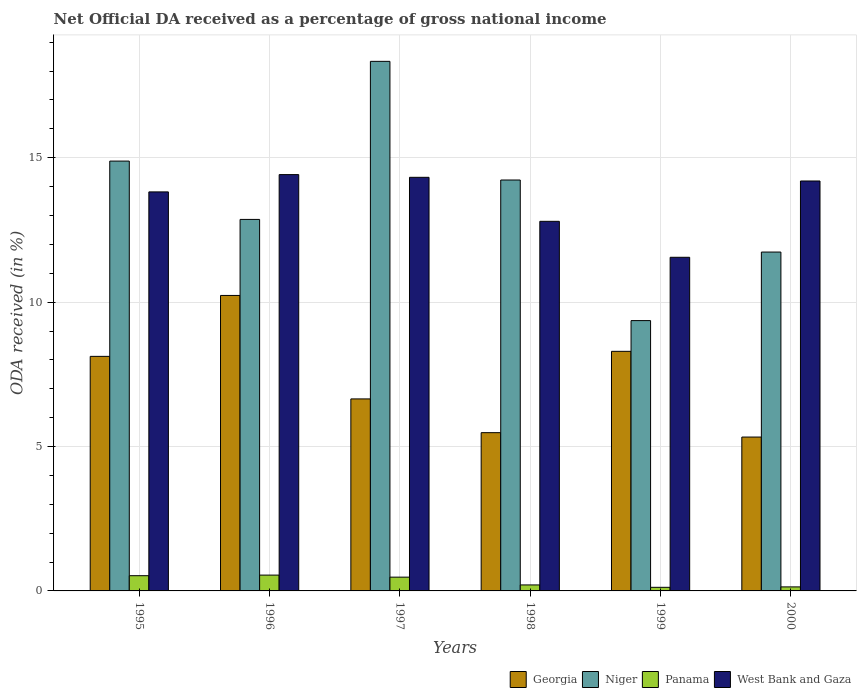How many different coloured bars are there?
Give a very brief answer. 4. Are the number of bars per tick equal to the number of legend labels?
Give a very brief answer. Yes. How many bars are there on the 4th tick from the left?
Give a very brief answer. 4. How many bars are there on the 1st tick from the right?
Provide a short and direct response. 4. What is the net official DA received in West Bank and Gaza in 1997?
Provide a succinct answer. 14.32. Across all years, what is the maximum net official DA received in West Bank and Gaza?
Offer a terse response. 14.42. Across all years, what is the minimum net official DA received in Panama?
Your answer should be compact. 0.12. In which year was the net official DA received in Niger minimum?
Your answer should be compact. 1999. What is the total net official DA received in West Bank and Gaza in the graph?
Offer a very short reply. 81.1. What is the difference between the net official DA received in West Bank and Gaza in 1995 and that in 1997?
Provide a short and direct response. -0.51. What is the difference between the net official DA received in Niger in 1998 and the net official DA received in Panama in 1995?
Make the answer very short. 13.7. What is the average net official DA received in Panama per year?
Your answer should be compact. 0.34. In the year 2000, what is the difference between the net official DA received in Georgia and net official DA received in West Bank and Gaza?
Offer a terse response. -8.87. What is the ratio of the net official DA received in Panama in 1997 to that in 1998?
Provide a short and direct response. 2.3. What is the difference between the highest and the second highest net official DA received in West Bank and Gaza?
Provide a short and direct response. 0.09. What is the difference between the highest and the lowest net official DA received in Niger?
Your answer should be compact. 8.98. Is it the case that in every year, the sum of the net official DA received in Panama and net official DA received in Niger is greater than the sum of net official DA received in Georgia and net official DA received in West Bank and Gaza?
Give a very brief answer. No. What does the 1st bar from the left in 1999 represents?
Offer a terse response. Georgia. What does the 2nd bar from the right in 1996 represents?
Provide a short and direct response. Panama. How many years are there in the graph?
Your response must be concise. 6. Does the graph contain grids?
Provide a succinct answer. Yes. How many legend labels are there?
Ensure brevity in your answer.  4. How are the legend labels stacked?
Ensure brevity in your answer.  Horizontal. What is the title of the graph?
Offer a terse response. Net Official DA received as a percentage of gross national income. Does "Korea (Democratic)" appear as one of the legend labels in the graph?
Your response must be concise. No. What is the label or title of the Y-axis?
Ensure brevity in your answer.  ODA received (in %). What is the ODA received (in %) in Georgia in 1995?
Keep it short and to the point. 8.12. What is the ODA received (in %) in Niger in 1995?
Ensure brevity in your answer.  14.88. What is the ODA received (in %) of Panama in 1995?
Give a very brief answer. 0.53. What is the ODA received (in %) of West Bank and Gaza in 1995?
Provide a succinct answer. 13.82. What is the ODA received (in %) of Georgia in 1996?
Your answer should be very brief. 10.23. What is the ODA received (in %) in Niger in 1996?
Make the answer very short. 12.86. What is the ODA received (in %) in Panama in 1996?
Offer a very short reply. 0.55. What is the ODA received (in %) of West Bank and Gaza in 1996?
Make the answer very short. 14.42. What is the ODA received (in %) of Georgia in 1997?
Provide a succinct answer. 6.65. What is the ODA received (in %) of Niger in 1997?
Your response must be concise. 18.34. What is the ODA received (in %) of Panama in 1997?
Provide a succinct answer. 0.48. What is the ODA received (in %) of West Bank and Gaza in 1997?
Give a very brief answer. 14.32. What is the ODA received (in %) of Georgia in 1998?
Offer a terse response. 5.48. What is the ODA received (in %) of Niger in 1998?
Provide a short and direct response. 14.23. What is the ODA received (in %) of Panama in 1998?
Keep it short and to the point. 0.21. What is the ODA received (in %) in West Bank and Gaza in 1998?
Keep it short and to the point. 12.8. What is the ODA received (in %) of Georgia in 1999?
Make the answer very short. 8.3. What is the ODA received (in %) in Niger in 1999?
Ensure brevity in your answer.  9.36. What is the ODA received (in %) of Panama in 1999?
Your answer should be compact. 0.12. What is the ODA received (in %) in West Bank and Gaza in 1999?
Keep it short and to the point. 11.55. What is the ODA received (in %) in Georgia in 2000?
Offer a terse response. 5.33. What is the ODA received (in %) of Niger in 2000?
Make the answer very short. 11.73. What is the ODA received (in %) of Panama in 2000?
Your answer should be compact. 0.14. What is the ODA received (in %) of West Bank and Gaza in 2000?
Ensure brevity in your answer.  14.19. Across all years, what is the maximum ODA received (in %) of Georgia?
Ensure brevity in your answer.  10.23. Across all years, what is the maximum ODA received (in %) of Niger?
Ensure brevity in your answer.  18.34. Across all years, what is the maximum ODA received (in %) of Panama?
Give a very brief answer. 0.55. Across all years, what is the maximum ODA received (in %) in West Bank and Gaza?
Ensure brevity in your answer.  14.42. Across all years, what is the minimum ODA received (in %) in Georgia?
Keep it short and to the point. 5.33. Across all years, what is the minimum ODA received (in %) of Niger?
Keep it short and to the point. 9.36. Across all years, what is the minimum ODA received (in %) in Panama?
Your answer should be compact. 0.12. Across all years, what is the minimum ODA received (in %) in West Bank and Gaza?
Keep it short and to the point. 11.55. What is the total ODA received (in %) of Georgia in the graph?
Your answer should be compact. 44.11. What is the total ODA received (in %) of Niger in the graph?
Ensure brevity in your answer.  81.41. What is the total ODA received (in %) in Panama in the graph?
Ensure brevity in your answer.  2.02. What is the total ODA received (in %) in West Bank and Gaza in the graph?
Keep it short and to the point. 81.1. What is the difference between the ODA received (in %) of Georgia in 1995 and that in 1996?
Give a very brief answer. -2.11. What is the difference between the ODA received (in %) of Niger in 1995 and that in 1996?
Provide a short and direct response. 2.02. What is the difference between the ODA received (in %) in Panama in 1995 and that in 1996?
Keep it short and to the point. -0.02. What is the difference between the ODA received (in %) of West Bank and Gaza in 1995 and that in 1996?
Offer a very short reply. -0.6. What is the difference between the ODA received (in %) of Georgia in 1995 and that in 1997?
Provide a short and direct response. 1.47. What is the difference between the ODA received (in %) of Niger in 1995 and that in 1997?
Your answer should be compact. -3.45. What is the difference between the ODA received (in %) of Panama in 1995 and that in 1997?
Ensure brevity in your answer.  0.05. What is the difference between the ODA received (in %) of West Bank and Gaza in 1995 and that in 1997?
Provide a short and direct response. -0.51. What is the difference between the ODA received (in %) of Georgia in 1995 and that in 1998?
Provide a succinct answer. 2.64. What is the difference between the ODA received (in %) of Niger in 1995 and that in 1998?
Provide a short and direct response. 0.66. What is the difference between the ODA received (in %) of Panama in 1995 and that in 1998?
Give a very brief answer. 0.32. What is the difference between the ODA received (in %) of West Bank and Gaza in 1995 and that in 1998?
Your response must be concise. 1.02. What is the difference between the ODA received (in %) in Georgia in 1995 and that in 1999?
Your answer should be very brief. -0.17. What is the difference between the ODA received (in %) of Niger in 1995 and that in 1999?
Ensure brevity in your answer.  5.52. What is the difference between the ODA received (in %) of Panama in 1995 and that in 1999?
Provide a succinct answer. 0.4. What is the difference between the ODA received (in %) in West Bank and Gaza in 1995 and that in 1999?
Give a very brief answer. 2.26. What is the difference between the ODA received (in %) of Georgia in 1995 and that in 2000?
Offer a terse response. 2.79. What is the difference between the ODA received (in %) of Niger in 1995 and that in 2000?
Provide a short and direct response. 3.15. What is the difference between the ODA received (in %) of Panama in 1995 and that in 2000?
Provide a short and direct response. 0.39. What is the difference between the ODA received (in %) in West Bank and Gaza in 1995 and that in 2000?
Keep it short and to the point. -0.38. What is the difference between the ODA received (in %) of Georgia in 1996 and that in 1997?
Provide a short and direct response. 3.58. What is the difference between the ODA received (in %) of Niger in 1996 and that in 1997?
Ensure brevity in your answer.  -5.47. What is the difference between the ODA received (in %) of Panama in 1996 and that in 1997?
Provide a succinct answer. 0.07. What is the difference between the ODA received (in %) of West Bank and Gaza in 1996 and that in 1997?
Your answer should be very brief. 0.09. What is the difference between the ODA received (in %) of Georgia in 1996 and that in 1998?
Your response must be concise. 4.75. What is the difference between the ODA received (in %) in Niger in 1996 and that in 1998?
Your answer should be very brief. -1.36. What is the difference between the ODA received (in %) of Panama in 1996 and that in 1998?
Give a very brief answer. 0.34. What is the difference between the ODA received (in %) in West Bank and Gaza in 1996 and that in 1998?
Offer a terse response. 1.62. What is the difference between the ODA received (in %) of Georgia in 1996 and that in 1999?
Offer a very short reply. 1.94. What is the difference between the ODA received (in %) in Niger in 1996 and that in 1999?
Offer a very short reply. 3.5. What is the difference between the ODA received (in %) of Panama in 1996 and that in 1999?
Provide a short and direct response. 0.42. What is the difference between the ODA received (in %) in West Bank and Gaza in 1996 and that in 1999?
Keep it short and to the point. 2.86. What is the difference between the ODA received (in %) in Georgia in 1996 and that in 2000?
Offer a very short reply. 4.9. What is the difference between the ODA received (in %) of Niger in 1996 and that in 2000?
Give a very brief answer. 1.13. What is the difference between the ODA received (in %) in Panama in 1996 and that in 2000?
Offer a very short reply. 0.41. What is the difference between the ODA received (in %) in West Bank and Gaza in 1996 and that in 2000?
Your answer should be very brief. 0.22. What is the difference between the ODA received (in %) in Georgia in 1997 and that in 1998?
Ensure brevity in your answer.  1.17. What is the difference between the ODA received (in %) in Niger in 1997 and that in 1998?
Your answer should be very brief. 4.11. What is the difference between the ODA received (in %) in Panama in 1997 and that in 1998?
Provide a succinct answer. 0.27. What is the difference between the ODA received (in %) in West Bank and Gaza in 1997 and that in 1998?
Your answer should be very brief. 1.52. What is the difference between the ODA received (in %) in Georgia in 1997 and that in 1999?
Offer a very short reply. -1.65. What is the difference between the ODA received (in %) of Niger in 1997 and that in 1999?
Your response must be concise. 8.98. What is the difference between the ODA received (in %) in Panama in 1997 and that in 1999?
Give a very brief answer. 0.35. What is the difference between the ODA received (in %) of West Bank and Gaza in 1997 and that in 1999?
Offer a very short reply. 2.77. What is the difference between the ODA received (in %) in Georgia in 1997 and that in 2000?
Your answer should be compact. 1.32. What is the difference between the ODA received (in %) in Niger in 1997 and that in 2000?
Offer a terse response. 6.6. What is the difference between the ODA received (in %) in Panama in 1997 and that in 2000?
Provide a short and direct response. 0.34. What is the difference between the ODA received (in %) of West Bank and Gaza in 1997 and that in 2000?
Give a very brief answer. 0.13. What is the difference between the ODA received (in %) of Georgia in 1998 and that in 1999?
Provide a succinct answer. -2.82. What is the difference between the ODA received (in %) of Niger in 1998 and that in 1999?
Provide a succinct answer. 4.87. What is the difference between the ODA received (in %) of Panama in 1998 and that in 1999?
Make the answer very short. 0.08. What is the difference between the ODA received (in %) in West Bank and Gaza in 1998 and that in 1999?
Offer a terse response. 1.25. What is the difference between the ODA received (in %) of Georgia in 1998 and that in 2000?
Make the answer very short. 0.15. What is the difference between the ODA received (in %) in Niger in 1998 and that in 2000?
Provide a succinct answer. 2.49. What is the difference between the ODA received (in %) in Panama in 1998 and that in 2000?
Give a very brief answer. 0.07. What is the difference between the ODA received (in %) in West Bank and Gaza in 1998 and that in 2000?
Provide a short and direct response. -1.4. What is the difference between the ODA received (in %) of Georgia in 1999 and that in 2000?
Ensure brevity in your answer.  2.97. What is the difference between the ODA received (in %) of Niger in 1999 and that in 2000?
Your response must be concise. -2.37. What is the difference between the ODA received (in %) of Panama in 1999 and that in 2000?
Offer a very short reply. -0.01. What is the difference between the ODA received (in %) of West Bank and Gaza in 1999 and that in 2000?
Offer a very short reply. -2.64. What is the difference between the ODA received (in %) in Georgia in 1995 and the ODA received (in %) in Niger in 1996?
Your answer should be very brief. -4.74. What is the difference between the ODA received (in %) in Georgia in 1995 and the ODA received (in %) in Panama in 1996?
Give a very brief answer. 7.57. What is the difference between the ODA received (in %) of Georgia in 1995 and the ODA received (in %) of West Bank and Gaza in 1996?
Provide a succinct answer. -6.29. What is the difference between the ODA received (in %) of Niger in 1995 and the ODA received (in %) of Panama in 1996?
Provide a succinct answer. 14.34. What is the difference between the ODA received (in %) of Niger in 1995 and the ODA received (in %) of West Bank and Gaza in 1996?
Your response must be concise. 0.47. What is the difference between the ODA received (in %) of Panama in 1995 and the ODA received (in %) of West Bank and Gaza in 1996?
Ensure brevity in your answer.  -13.89. What is the difference between the ODA received (in %) of Georgia in 1995 and the ODA received (in %) of Niger in 1997?
Make the answer very short. -10.22. What is the difference between the ODA received (in %) in Georgia in 1995 and the ODA received (in %) in Panama in 1997?
Give a very brief answer. 7.64. What is the difference between the ODA received (in %) in Georgia in 1995 and the ODA received (in %) in West Bank and Gaza in 1997?
Offer a very short reply. -6.2. What is the difference between the ODA received (in %) in Niger in 1995 and the ODA received (in %) in Panama in 1997?
Ensure brevity in your answer.  14.41. What is the difference between the ODA received (in %) in Niger in 1995 and the ODA received (in %) in West Bank and Gaza in 1997?
Your answer should be compact. 0.56. What is the difference between the ODA received (in %) of Panama in 1995 and the ODA received (in %) of West Bank and Gaza in 1997?
Keep it short and to the point. -13.79. What is the difference between the ODA received (in %) in Georgia in 1995 and the ODA received (in %) in Niger in 1998?
Your answer should be compact. -6.11. What is the difference between the ODA received (in %) in Georgia in 1995 and the ODA received (in %) in Panama in 1998?
Offer a terse response. 7.91. What is the difference between the ODA received (in %) of Georgia in 1995 and the ODA received (in %) of West Bank and Gaza in 1998?
Your response must be concise. -4.68. What is the difference between the ODA received (in %) of Niger in 1995 and the ODA received (in %) of Panama in 1998?
Your answer should be very brief. 14.68. What is the difference between the ODA received (in %) in Niger in 1995 and the ODA received (in %) in West Bank and Gaza in 1998?
Your answer should be very brief. 2.09. What is the difference between the ODA received (in %) in Panama in 1995 and the ODA received (in %) in West Bank and Gaza in 1998?
Give a very brief answer. -12.27. What is the difference between the ODA received (in %) of Georgia in 1995 and the ODA received (in %) of Niger in 1999?
Give a very brief answer. -1.24. What is the difference between the ODA received (in %) in Georgia in 1995 and the ODA received (in %) in Panama in 1999?
Offer a terse response. 8. What is the difference between the ODA received (in %) of Georgia in 1995 and the ODA received (in %) of West Bank and Gaza in 1999?
Ensure brevity in your answer.  -3.43. What is the difference between the ODA received (in %) in Niger in 1995 and the ODA received (in %) in Panama in 1999?
Provide a short and direct response. 14.76. What is the difference between the ODA received (in %) of Niger in 1995 and the ODA received (in %) of West Bank and Gaza in 1999?
Your response must be concise. 3.33. What is the difference between the ODA received (in %) of Panama in 1995 and the ODA received (in %) of West Bank and Gaza in 1999?
Offer a very short reply. -11.03. What is the difference between the ODA received (in %) of Georgia in 1995 and the ODA received (in %) of Niger in 2000?
Provide a short and direct response. -3.61. What is the difference between the ODA received (in %) in Georgia in 1995 and the ODA received (in %) in Panama in 2000?
Offer a terse response. 7.98. What is the difference between the ODA received (in %) of Georgia in 1995 and the ODA received (in %) of West Bank and Gaza in 2000?
Ensure brevity in your answer.  -6.07. What is the difference between the ODA received (in %) in Niger in 1995 and the ODA received (in %) in Panama in 2000?
Offer a very short reply. 14.74. What is the difference between the ODA received (in %) in Niger in 1995 and the ODA received (in %) in West Bank and Gaza in 2000?
Make the answer very short. 0.69. What is the difference between the ODA received (in %) in Panama in 1995 and the ODA received (in %) in West Bank and Gaza in 2000?
Provide a succinct answer. -13.67. What is the difference between the ODA received (in %) of Georgia in 1996 and the ODA received (in %) of Niger in 1997?
Provide a succinct answer. -8.11. What is the difference between the ODA received (in %) of Georgia in 1996 and the ODA received (in %) of Panama in 1997?
Give a very brief answer. 9.75. What is the difference between the ODA received (in %) in Georgia in 1996 and the ODA received (in %) in West Bank and Gaza in 1997?
Provide a succinct answer. -4.09. What is the difference between the ODA received (in %) in Niger in 1996 and the ODA received (in %) in Panama in 1997?
Make the answer very short. 12.39. What is the difference between the ODA received (in %) in Niger in 1996 and the ODA received (in %) in West Bank and Gaza in 1997?
Your response must be concise. -1.46. What is the difference between the ODA received (in %) of Panama in 1996 and the ODA received (in %) of West Bank and Gaza in 1997?
Provide a short and direct response. -13.77. What is the difference between the ODA received (in %) in Georgia in 1996 and the ODA received (in %) in Niger in 1998?
Offer a very short reply. -4. What is the difference between the ODA received (in %) of Georgia in 1996 and the ODA received (in %) of Panama in 1998?
Ensure brevity in your answer.  10.02. What is the difference between the ODA received (in %) in Georgia in 1996 and the ODA received (in %) in West Bank and Gaza in 1998?
Give a very brief answer. -2.57. What is the difference between the ODA received (in %) of Niger in 1996 and the ODA received (in %) of Panama in 1998?
Offer a terse response. 12.66. What is the difference between the ODA received (in %) of Niger in 1996 and the ODA received (in %) of West Bank and Gaza in 1998?
Ensure brevity in your answer.  0.07. What is the difference between the ODA received (in %) in Panama in 1996 and the ODA received (in %) in West Bank and Gaza in 1998?
Your answer should be very brief. -12.25. What is the difference between the ODA received (in %) in Georgia in 1996 and the ODA received (in %) in Niger in 1999?
Provide a succinct answer. 0.87. What is the difference between the ODA received (in %) in Georgia in 1996 and the ODA received (in %) in Panama in 1999?
Provide a short and direct response. 10.11. What is the difference between the ODA received (in %) in Georgia in 1996 and the ODA received (in %) in West Bank and Gaza in 1999?
Your answer should be very brief. -1.32. What is the difference between the ODA received (in %) of Niger in 1996 and the ODA received (in %) of Panama in 1999?
Provide a succinct answer. 12.74. What is the difference between the ODA received (in %) of Niger in 1996 and the ODA received (in %) of West Bank and Gaza in 1999?
Your answer should be very brief. 1.31. What is the difference between the ODA received (in %) in Panama in 1996 and the ODA received (in %) in West Bank and Gaza in 1999?
Your answer should be very brief. -11. What is the difference between the ODA received (in %) in Georgia in 1996 and the ODA received (in %) in Niger in 2000?
Make the answer very short. -1.5. What is the difference between the ODA received (in %) in Georgia in 1996 and the ODA received (in %) in Panama in 2000?
Keep it short and to the point. 10.09. What is the difference between the ODA received (in %) of Georgia in 1996 and the ODA received (in %) of West Bank and Gaza in 2000?
Your answer should be very brief. -3.96. What is the difference between the ODA received (in %) in Niger in 1996 and the ODA received (in %) in Panama in 2000?
Keep it short and to the point. 12.72. What is the difference between the ODA received (in %) of Niger in 1996 and the ODA received (in %) of West Bank and Gaza in 2000?
Keep it short and to the point. -1.33. What is the difference between the ODA received (in %) of Panama in 1996 and the ODA received (in %) of West Bank and Gaza in 2000?
Your answer should be compact. -13.65. What is the difference between the ODA received (in %) of Georgia in 1997 and the ODA received (in %) of Niger in 1998?
Offer a very short reply. -7.58. What is the difference between the ODA received (in %) in Georgia in 1997 and the ODA received (in %) in Panama in 1998?
Give a very brief answer. 6.44. What is the difference between the ODA received (in %) in Georgia in 1997 and the ODA received (in %) in West Bank and Gaza in 1998?
Your response must be concise. -6.15. What is the difference between the ODA received (in %) in Niger in 1997 and the ODA received (in %) in Panama in 1998?
Offer a very short reply. 18.13. What is the difference between the ODA received (in %) of Niger in 1997 and the ODA received (in %) of West Bank and Gaza in 1998?
Give a very brief answer. 5.54. What is the difference between the ODA received (in %) in Panama in 1997 and the ODA received (in %) in West Bank and Gaza in 1998?
Offer a very short reply. -12.32. What is the difference between the ODA received (in %) in Georgia in 1997 and the ODA received (in %) in Niger in 1999?
Keep it short and to the point. -2.71. What is the difference between the ODA received (in %) of Georgia in 1997 and the ODA received (in %) of Panama in 1999?
Give a very brief answer. 6.52. What is the difference between the ODA received (in %) of Georgia in 1997 and the ODA received (in %) of West Bank and Gaza in 1999?
Make the answer very short. -4.9. What is the difference between the ODA received (in %) of Niger in 1997 and the ODA received (in %) of Panama in 1999?
Offer a terse response. 18.21. What is the difference between the ODA received (in %) in Niger in 1997 and the ODA received (in %) in West Bank and Gaza in 1999?
Make the answer very short. 6.78. What is the difference between the ODA received (in %) in Panama in 1997 and the ODA received (in %) in West Bank and Gaza in 1999?
Keep it short and to the point. -11.08. What is the difference between the ODA received (in %) of Georgia in 1997 and the ODA received (in %) of Niger in 2000?
Offer a very short reply. -5.09. What is the difference between the ODA received (in %) in Georgia in 1997 and the ODA received (in %) in Panama in 2000?
Provide a short and direct response. 6.51. What is the difference between the ODA received (in %) of Georgia in 1997 and the ODA received (in %) of West Bank and Gaza in 2000?
Your answer should be compact. -7.55. What is the difference between the ODA received (in %) of Niger in 1997 and the ODA received (in %) of Panama in 2000?
Provide a short and direct response. 18.2. What is the difference between the ODA received (in %) of Niger in 1997 and the ODA received (in %) of West Bank and Gaza in 2000?
Provide a succinct answer. 4.14. What is the difference between the ODA received (in %) in Panama in 1997 and the ODA received (in %) in West Bank and Gaza in 2000?
Your response must be concise. -13.72. What is the difference between the ODA received (in %) of Georgia in 1998 and the ODA received (in %) of Niger in 1999?
Offer a terse response. -3.88. What is the difference between the ODA received (in %) in Georgia in 1998 and the ODA received (in %) in Panama in 1999?
Make the answer very short. 5.36. What is the difference between the ODA received (in %) of Georgia in 1998 and the ODA received (in %) of West Bank and Gaza in 1999?
Make the answer very short. -6.07. What is the difference between the ODA received (in %) in Niger in 1998 and the ODA received (in %) in Panama in 1999?
Your answer should be compact. 14.1. What is the difference between the ODA received (in %) of Niger in 1998 and the ODA received (in %) of West Bank and Gaza in 1999?
Provide a succinct answer. 2.68. What is the difference between the ODA received (in %) in Panama in 1998 and the ODA received (in %) in West Bank and Gaza in 1999?
Provide a succinct answer. -11.35. What is the difference between the ODA received (in %) in Georgia in 1998 and the ODA received (in %) in Niger in 2000?
Provide a succinct answer. -6.25. What is the difference between the ODA received (in %) in Georgia in 1998 and the ODA received (in %) in Panama in 2000?
Offer a terse response. 5.34. What is the difference between the ODA received (in %) in Georgia in 1998 and the ODA received (in %) in West Bank and Gaza in 2000?
Offer a very short reply. -8.71. What is the difference between the ODA received (in %) in Niger in 1998 and the ODA received (in %) in Panama in 2000?
Provide a succinct answer. 14.09. What is the difference between the ODA received (in %) of Niger in 1998 and the ODA received (in %) of West Bank and Gaza in 2000?
Offer a terse response. 0.03. What is the difference between the ODA received (in %) of Panama in 1998 and the ODA received (in %) of West Bank and Gaza in 2000?
Give a very brief answer. -13.99. What is the difference between the ODA received (in %) in Georgia in 1999 and the ODA received (in %) in Niger in 2000?
Your answer should be very brief. -3.44. What is the difference between the ODA received (in %) of Georgia in 1999 and the ODA received (in %) of Panama in 2000?
Give a very brief answer. 8.16. What is the difference between the ODA received (in %) in Georgia in 1999 and the ODA received (in %) in West Bank and Gaza in 2000?
Give a very brief answer. -5.9. What is the difference between the ODA received (in %) in Niger in 1999 and the ODA received (in %) in Panama in 2000?
Provide a short and direct response. 9.22. What is the difference between the ODA received (in %) in Niger in 1999 and the ODA received (in %) in West Bank and Gaza in 2000?
Your response must be concise. -4.83. What is the difference between the ODA received (in %) of Panama in 1999 and the ODA received (in %) of West Bank and Gaza in 2000?
Offer a very short reply. -14.07. What is the average ODA received (in %) in Georgia per year?
Ensure brevity in your answer.  7.35. What is the average ODA received (in %) of Niger per year?
Ensure brevity in your answer.  13.57. What is the average ODA received (in %) in Panama per year?
Make the answer very short. 0.34. What is the average ODA received (in %) of West Bank and Gaza per year?
Give a very brief answer. 13.52. In the year 1995, what is the difference between the ODA received (in %) of Georgia and ODA received (in %) of Niger?
Your answer should be compact. -6.76. In the year 1995, what is the difference between the ODA received (in %) of Georgia and ODA received (in %) of Panama?
Your response must be concise. 7.59. In the year 1995, what is the difference between the ODA received (in %) of Georgia and ODA received (in %) of West Bank and Gaza?
Provide a short and direct response. -5.7. In the year 1995, what is the difference between the ODA received (in %) of Niger and ODA received (in %) of Panama?
Your answer should be compact. 14.36. In the year 1995, what is the difference between the ODA received (in %) of Niger and ODA received (in %) of West Bank and Gaza?
Give a very brief answer. 1.07. In the year 1995, what is the difference between the ODA received (in %) in Panama and ODA received (in %) in West Bank and Gaza?
Your answer should be compact. -13.29. In the year 1996, what is the difference between the ODA received (in %) of Georgia and ODA received (in %) of Niger?
Make the answer very short. -2.63. In the year 1996, what is the difference between the ODA received (in %) of Georgia and ODA received (in %) of Panama?
Your answer should be very brief. 9.68. In the year 1996, what is the difference between the ODA received (in %) in Georgia and ODA received (in %) in West Bank and Gaza?
Your response must be concise. -4.18. In the year 1996, what is the difference between the ODA received (in %) in Niger and ODA received (in %) in Panama?
Your answer should be compact. 12.32. In the year 1996, what is the difference between the ODA received (in %) in Niger and ODA received (in %) in West Bank and Gaza?
Offer a terse response. -1.55. In the year 1996, what is the difference between the ODA received (in %) of Panama and ODA received (in %) of West Bank and Gaza?
Offer a very short reply. -13.87. In the year 1997, what is the difference between the ODA received (in %) of Georgia and ODA received (in %) of Niger?
Make the answer very short. -11.69. In the year 1997, what is the difference between the ODA received (in %) in Georgia and ODA received (in %) in Panama?
Ensure brevity in your answer.  6.17. In the year 1997, what is the difference between the ODA received (in %) in Georgia and ODA received (in %) in West Bank and Gaza?
Keep it short and to the point. -7.67. In the year 1997, what is the difference between the ODA received (in %) of Niger and ODA received (in %) of Panama?
Your answer should be compact. 17.86. In the year 1997, what is the difference between the ODA received (in %) of Niger and ODA received (in %) of West Bank and Gaza?
Ensure brevity in your answer.  4.02. In the year 1997, what is the difference between the ODA received (in %) of Panama and ODA received (in %) of West Bank and Gaza?
Offer a very short reply. -13.84. In the year 1998, what is the difference between the ODA received (in %) in Georgia and ODA received (in %) in Niger?
Make the answer very short. -8.75. In the year 1998, what is the difference between the ODA received (in %) in Georgia and ODA received (in %) in Panama?
Your answer should be very brief. 5.27. In the year 1998, what is the difference between the ODA received (in %) in Georgia and ODA received (in %) in West Bank and Gaza?
Keep it short and to the point. -7.32. In the year 1998, what is the difference between the ODA received (in %) of Niger and ODA received (in %) of Panama?
Provide a short and direct response. 14.02. In the year 1998, what is the difference between the ODA received (in %) of Niger and ODA received (in %) of West Bank and Gaza?
Your answer should be compact. 1.43. In the year 1998, what is the difference between the ODA received (in %) of Panama and ODA received (in %) of West Bank and Gaza?
Provide a short and direct response. -12.59. In the year 1999, what is the difference between the ODA received (in %) in Georgia and ODA received (in %) in Niger?
Offer a very short reply. -1.06. In the year 1999, what is the difference between the ODA received (in %) of Georgia and ODA received (in %) of Panama?
Keep it short and to the point. 8.17. In the year 1999, what is the difference between the ODA received (in %) in Georgia and ODA received (in %) in West Bank and Gaza?
Your response must be concise. -3.26. In the year 1999, what is the difference between the ODA received (in %) of Niger and ODA received (in %) of Panama?
Provide a short and direct response. 9.24. In the year 1999, what is the difference between the ODA received (in %) of Niger and ODA received (in %) of West Bank and Gaza?
Your response must be concise. -2.19. In the year 1999, what is the difference between the ODA received (in %) in Panama and ODA received (in %) in West Bank and Gaza?
Ensure brevity in your answer.  -11.43. In the year 2000, what is the difference between the ODA received (in %) in Georgia and ODA received (in %) in Niger?
Your answer should be very brief. -6.41. In the year 2000, what is the difference between the ODA received (in %) in Georgia and ODA received (in %) in Panama?
Provide a short and direct response. 5.19. In the year 2000, what is the difference between the ODA received (in %) of Georgia and ODA received (in %) of West Bank and Gaza?
Make the answer very short. -8.87. In the year 2000, what is the difference between the ODA received (in %) of Niger and ODA received (in %) of Panama?
Offer a very short reply. 11.59. In the year 2000, what is the difference between the ODA received (in %) of Niger and ODA received (in %) of West Bank and Gaza?
Offer a very short reply. -2.46. In the year 2000, what is the difference between the ODA received (in %) in Panama and ODA received (in %) in West Bank and Gaza?
Offer a terse response. -14.05. What is the ratio of the ODA received (in %) in Georgia in 1995 to that in 1996?
Make the answer very short. 0.79. What is the ratio of the ODA received (in %) of Niger in 1995 to that in 1996?
Give a very brief answer. 1.16. What is the ratio of the ODA received (in %) in Panama in 1995 to that in 1996?
Offer a very short reply. 0.96. What is the ratio of the ODA received (in %) in West Bank and Gaza in 1995 to that in 1996?
Your answer should be compact. 0.96. What is the ratio of the ODA received (in %) in Georgia in 1995 to that in 1997?
Make the answer very short. 1.22. What is the ratio of the ODA received (in %) in Niger in 1995 to that in 1997?
Your answer should be very brief. 0.81. What is the ratio of the ODA received (in %) of Panama in 1995 to that in 1997?
Provide a short and direct response. 1.11. What is the ratio of the ODA received (in %) in West Bank and Gaza in 1995 to that in 1997?
Ensure brevity in your answer.  0.96. What is the ratio of the ODA received (in %) of Georgia in 1995 to that in 1998?
Ensure brevity in your answer.  1.48. What is the ratio of the ODA received (in %) of Niger in 1995 to that in 1998?
Provide a succinct answer. 1.05. What is the ratio of the ODA received (in %) in Panama in 1995 to that in 1998?
Your response must be concise. 2.54. What is the ratio of the ODA received (in %) in West Bank and Gaza in 1995 to that in 1998?
Your response must be concise. 1.08. What is the ratio of the ODA received (in %) in Georgia in 1995 to that in 1999?
Offer a terse response. 0.98. What is the ratio of the ODA received (in %) in Niger in 1995 to that in 1999?
Your answer should be compact. 1.59. What is the ratio of the ODA received (in %) of Panama in 1995 to that in 1999?
Provide a short and direct response. 4.23. What is the ratio of the ODA received (in %) of West Bank and Gaza in 1995 to that in 1999?
Ensure brevity in your answer.  1.2. What is the ratio of the ODA received (in %) in Georgia in 1995 to that in 2000?
Make the answer very short. 1.52. What is the ratio of the ODA received (in %) of Niger in 1995 to that in 2000?
Keep it short and to the point. 1.27. What is the ratio of the ODA received (in %) of Panama in 1995 to that in 2000?
Your answer should be compact. 3.78. What is the ratio of the ODA received (in %) in West Bank and Gaza in 1995 to that in 2000?
Provide a succinct answer. 0.97. What is the ratio of the ODA received (in %) of Georgia in 1996 to that in 1997?
Make the answer very short. 1.54. What is the ratio of the ODA received (in %) in Niger in 1996 to that in 1997?
Provide a succinct answer. 0.7. What is the ratio of the ODA received (in %) in Panama in 1996 to that in 1997?
Provide a short and direct response. 1.15. What is the ratio of the ODA received (in %) of West Bank and Gaza in 1996 to that in 1997?
Offer a very short reply. 1.01. What is the ratio of the ODA received (in %) in Georgia in 1996 to that in 1998?
Give a very brief answer. 1.87. What is the ratio of the ODA received (in %) of Niger in 1996 to that in 1998?
Ensure brevity in your answer.  0.9. What is the ratio of the ODA received (in %) in Panama in 1996 to that in 1998?
Provide a succinct answer. 2.64. What is the ratio of the ODA received (in %) of West Bank and Gaza in 1996 to that in 1998?
Your answer should be very brief. 1.13. What is the ratio of the ODA received (in %) in Georgia in 1996 to that in 1999?
Make the answer very short. 1.23. What is the ratio of the ODA received (in %) in Niger in 1996 to that in 1999?
Offer a very short reply. 1.37. What is the ratio of the ODA received (in %) of Panama in 1996 to that in 1999?
Offer a terse response. 4.4. What is the ratio of the ODA received (in %) in West Bank and Gaza in 1996 to that in 1999?
Your answer should be compact. 1.25. What is the ratio of the ODA received (in %) of Georgia in 1996 to that in 2000?
Offer a very short reply. 1.92. What is the ratio of the ODA received (in %) in Niger in 1996 to that in 2000?
Keep it short and to the point. 1.1. What is the ratio of the ODA received (in %) of Panama in 1996 to that in 2000?
Offer a very short reply. 3.93. What is the ratio of the ODA received (in %) of West Bank and Gaza in 1996 to that in 2000?
Offer a very short reply. 1.02. What is the ratio of the ODA received (in %) in Georgia in 1997 to that in 1998?
Give a very brief answer. 1.21. What is the ratio of the ODA received (in %) of Niger in 1997 to that in 1998?
Offer a very short reply. 1.29. What is the ratio of the ODA received (in %) in Panama in 1997 to that in 1998?
Make the answer very short. 2.3. What is the ratio of the ODA received (in %) of West Bank and Gaza in 1997 to that in 1998?
Provide a short and direct response. 1.12. What is the ratio of the ODA received (in %) of Georgia in 1997 to that in 1999?
Provide a succinct answer. 0.8. What is the ratio of the ODA received (in %) of Niger in 1997 to that in 1999?
Your response must be concise. 1.96. What is the ratio of the ODA received (in %) in Panama in 1997 to that in 1999?
Your response must be concise. 3.83. What is the ratio of the ODA received (in %) in West Bank and Gaza in 1997 to that in 1999?
Make the answer very short. 1.24. What is the ratio of the ODA received (in %) of Georgia in 1997 to that in 2000?
Make the answer very short. 1.25. What is the ratio of the ODA received (in %) of Niger in 1997 to that in 2000?
Ensure brevity in your answer.  1.56. What is the ratio of the ODA received (in %) in Panama in 1997 to that in 2000?
Offer a very short reply. 3.42. What is the ratio of the ODA received (in %) in Georgia in 1998 to that in 1999?
Your response must be concise. 0.66. What is the ratio of the ODA received (in %) of Niger in 1998 to that in 1999?
Ensure brevity in your answer.  1.52. What is the ratio of the ODA received (in %) in Panama in 1998 to that in 1999?
Provide a short and direct response. 1.66. What is the ratio of the ODA received (in %) of West Bank and Gaza in 1998 to that in 1999?
Your response must be concise. 1.11. What is the ratio of the ODA received (in %) in Georgia in 1998 to that in 2000?
Provide a succinct answer. 1.03. What is the ratio of the ODA received (in %) in Niger in 1998 to that in 2000?
Give a very brief answer. 1.21. What is the ratio of the ODA received (in %) in Panama in 1998 to that in 2000?
Give a very brief answer. 1.49. What is the ratio of the ODA received (in %) of West Bank and Gaza in 1998 to that in 2000?
Offer a very short reply. 0.9. What is the ratio of the ODA received (in %) in Georgia in 1999 to that in 2000?
Your answer should be very brief. 1.56. What is the ratio of the ODA received (in %) in Niger in 1999 to that in 2000?
Your answer should be very brief. 0.8. What is the ratio of the ODA received (in %) of Panama in 1999 to that in 2000?
Make the answer very short. 0.89. What is the ratio of the ODA received (in %) of West Bank and Gaza in 1999 to that in 2000?
Your answer should be compact. 0.81. What is the difference between the highest and the second highest ODA received (in %) of Georgia?
Ensure brevity in your answer.  1.94. What is the difference between the highest and the second highest ODA received (in %) in Niger?
Give a very brief answer. 3.45. What is the difference between the highest and the second highest ODA received (in %) in Panama?
Make the answer very short. 0.02. What is the difference between the highest and the second highest ODA received (in %) in West Bank and Gaza?
Make the answer very short. 0.09. What is the difference between the highest and the lowest ODA received (in %) of Georgia?
Give a very brief answer. 4.9. What is the difference between the highest and the lowest ODA received (in %) in Niger?
Your response must be concise. 8.98. What is the difference between the highest and the lowest ODA received (in %) in Panama?
Offer a very short reply. 0.42. What is the difference between the highest and the lowest ODA received (in %) of West Bank and Gaza?
Provide a short and direct response. 2.86. 